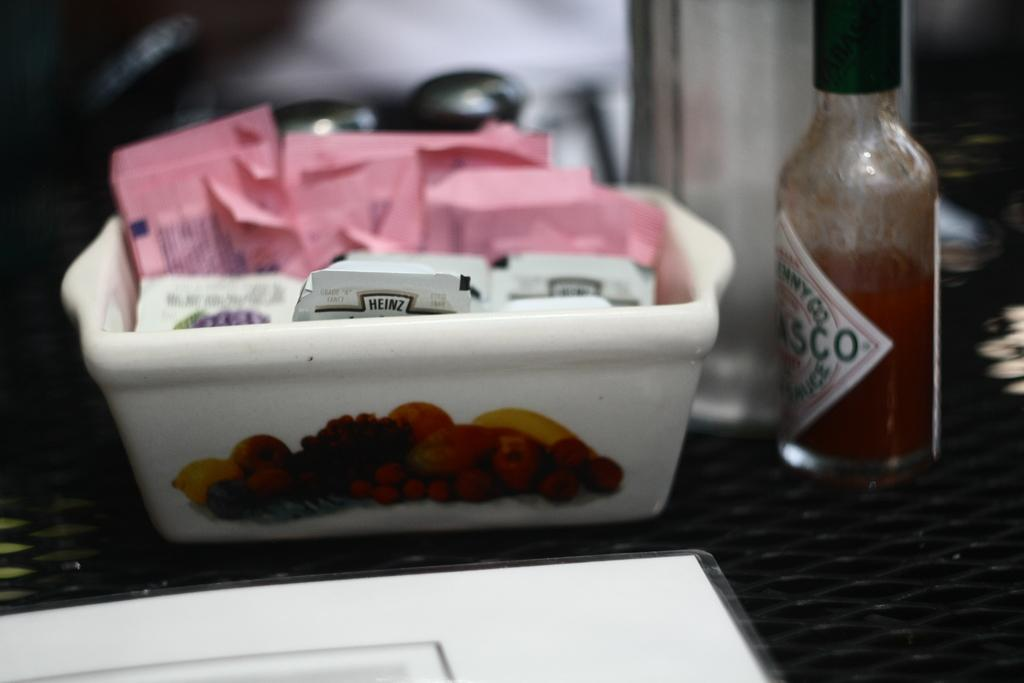<image>
Present a compact description of the photo's key features. A container that has sugar and jam from the brand Heinz. 